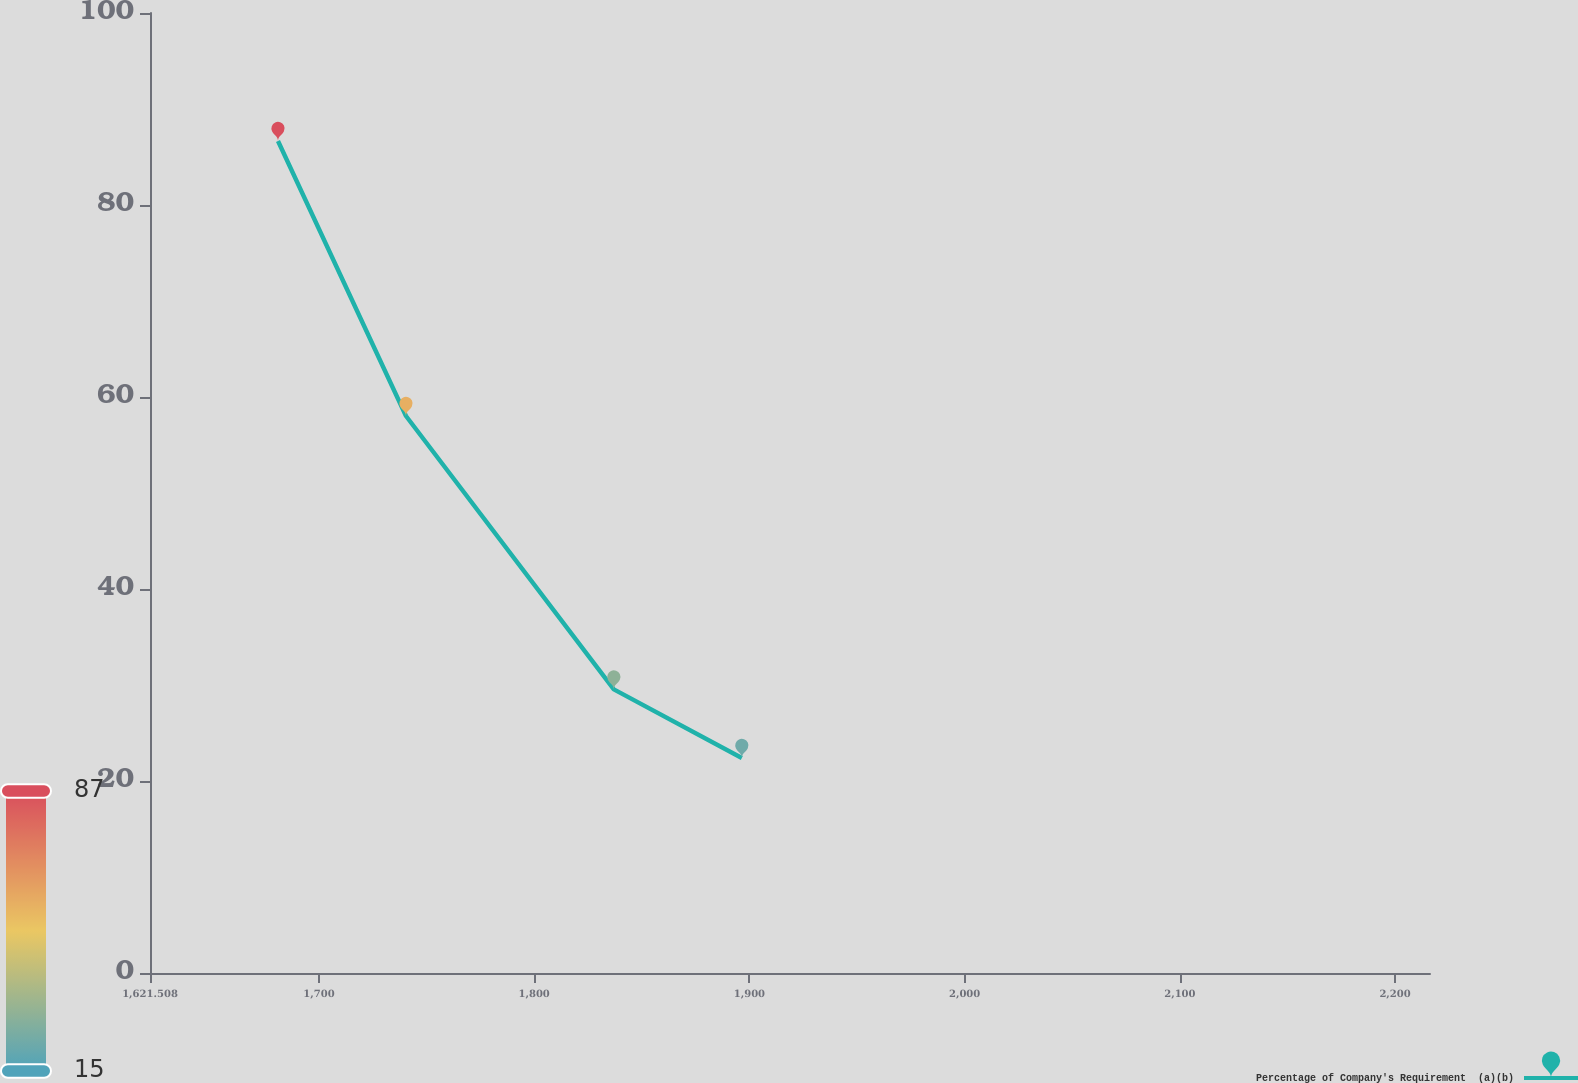Convert chart. <chart><loc_0><loc_0><loc_500><loc_500><line_chart><ecel><fcel>Percentage of Company's Requirement  (a)(b)<nl><fcel>1680.98<fcel>86.67<nl><fcel>1740.45<fcel>58.02<nl><fcel>1837.02<fcel>29.54<nl><fcel>1896.49<fcel>22.4<nl><fcel>2275.7<fcel>15.26<nl></chart> 